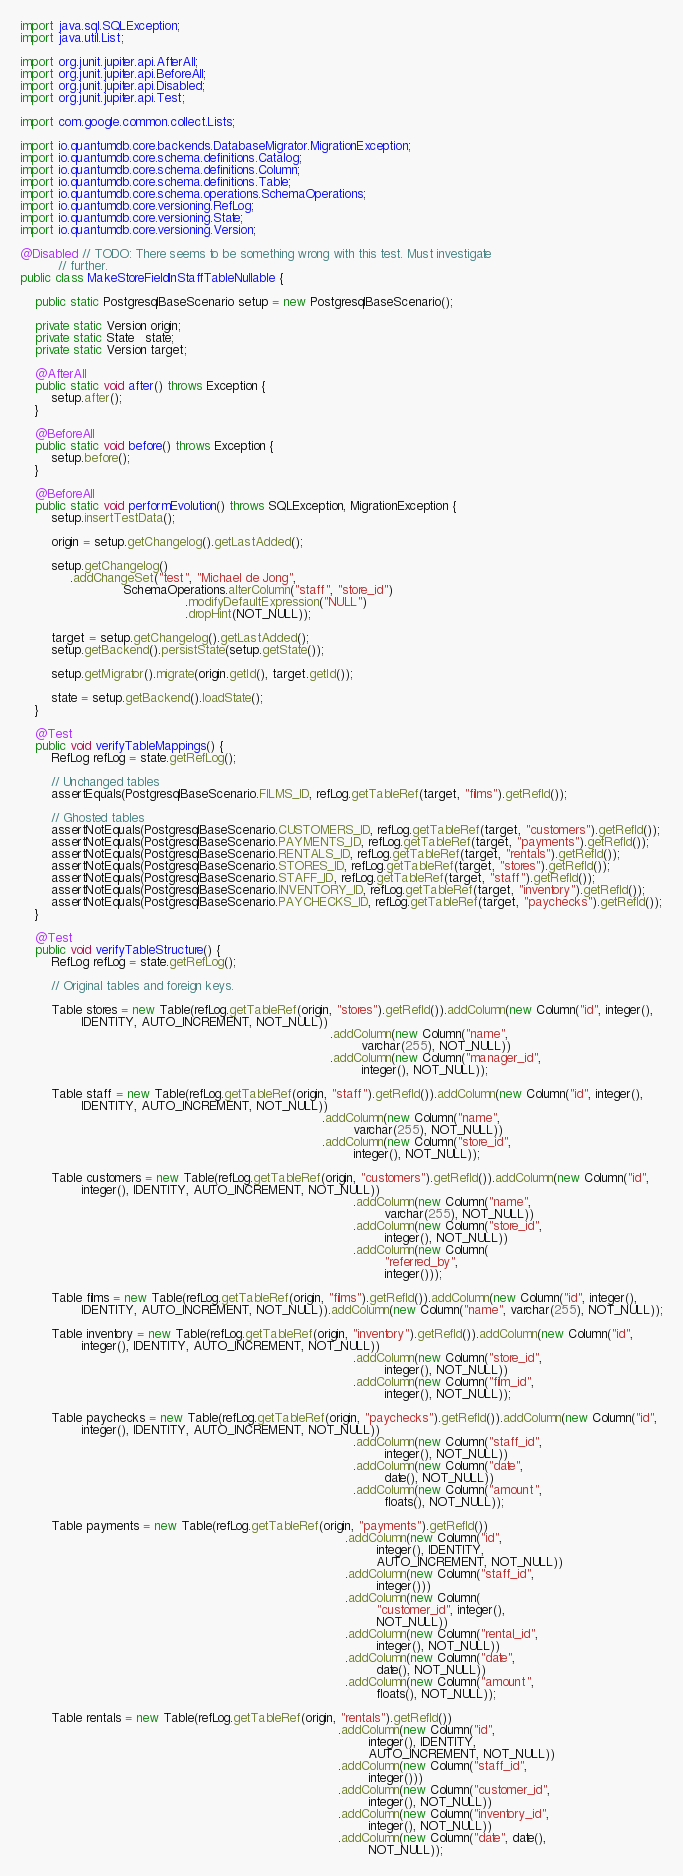<code> <loc_0><loc_0><loc_500><loc_500><_Java_>import java.sql.SQLException;
import java.util.List;

import org.junit.jupiter.api.AfterAll;
import org.junit.jupiter.api.BeforeAll;
import org.junit.jupiter.api.Disabled;
import org.junit.jupiter.api.Test;

import com.google.common.collect.Lists;

import io.quantumdb.core.backends.DatabaseMigrator.MigrationException;
import io.quantumdb.core.schema.definitions.Catalog;
import io.quantumdb.core.schema.definitions.Column;
import io.quantumdb.core.schema.definitions.Table;
import io.quantumdb.core.schema.operations.SchemaOperations;
import io.quantumdb.core.versioning.RefLog;
import io.quantumdb.core.versioning.State;
import io.quantumdb.core.versioning.Version;

@Disabled // TODO: There seems to be something wrong with this test. Must investigate
          // further.
public class MakeStoreFieldInStaffTableNullable {

    public static PostgresqlBaseScenario setup = new PostgresqlBaseScenario();

    private static Version origin;
    private static State   state;
    private static Version target;

    @AfterAll
    public static void after() throws Exception {
        setup.after();
    }

    @BeforeAll
    public static void before() throws Exception {
        setup.before();
    }

    @BeforeAll
    public static void performEvolution() throws SQLException, MigrationException {
        setup.insertTestData();

        origin = setup.getChangelog().getLastAdded();

        setup.getChangelog()
             .addChangeSet("test", "Michael de Jong",
                           SchemaOperations.alterColumn("staff", "store_id")
                                           .modifyDefaultExpression("NULL")
                                           .dropHint(NOT_NULL));

        target = setup.getChangelog().getLastAdded();
        setup.getBackend().persistState(setup.getState());

        setup.getMigrator().migrate(origin.getId(), target.getId());

        state = setup.getBackend().loadState();
    }

    @Test
    public void verifyTableMappings() {
        RefLog refLog = state.getRefLog();

        // Unchanged tables
        assertEquals(PostgresqlBaseScenario.FILMS_ID, refLog.getTableRef(target, "films").getRefId());

        // Ghosted tables
        assertNotEquals(PostgresqlBaseScenario.CUSTOMERS_ID, refLog.getTableRef(target, "customers").getRefId());
        assertNotEquals(PostgresqlBaseScenario.PAYMENTS_ID, refLog.getTableRef(target, "payments").getRefId());
        assertNotEquals(PostgresqlBaseScenario.RENTALS_ID, refLog.getTableRef(target, "rentals").getRefId());
        assertNotEquals(PostgresqlBaseScenario.STORES_ID, refLog.getTableRef(target, "stores").getRefId());
        assertNotEquals(PostgresqlBaseScenario.STAFF_ID, refLog.getTableRef(target, "staff").getRefId());
        assertNotEquals(PostgresqlBaseScenario.INVENTORY_ID, refLog.getTableRef(target, "inventory").getRefId());
        assertNotEquals(PostgresqlBaseScenario.PAYCHECKS_ID, refLog.getTableRef(target, "paychecks").getRefId());
    }

    @Test
    public void verifyTableStructure() {
        RefLog refLog = state.getRefLog();

        // Original tables and foreign keys.

        Table stores = new Table(refLog.getTableRef(origin, "stores").getRefId()).addColumn(new Column("id", integer(),
                IDENTITY, AUTO_INCREMENT, NOT_NULL))
                                                                                 .addColumn(new Column("name",
                                                                                         varchar(255), NOT_NULL))
                                                                                 .addColumn(new Column("manager_id",
                                                                                         integer(), NOT_NULL));

        Table staff = new Table(refLog.getTableRef(origin, "staff").getRefId()).addColumn(new Column("id", integer(),
                IDENTITY, AUTO_INCREMENT, NOT_NULL))
                                                                               .addColumn(new Column("name",
                                                                                       varchar(255), NOT_NULL))
                                                                               .addColumn(new Column("store_id",
                                                                                       integer(), NOT_NULL));

        Table customers = new Table(refLog.getTableRef(origin, "customers").getRefId()).addColumn(new Column("id",
                integer(), IDENTITY, AUTO_INCREMENT, NOT_NULL))
                                                                                       .addColumn(new Column("name",
                                                                                               varchar(255), NOT_NULL))
                                                                                       .addColumn(new Column("store_id",
                                                                                               integer(), NOT_NULL))
                                                                                       .addColumn(new Column(
                                                                                               "referred_by",
                                                                                               integer()));

        Table films = new Table(refLog.getTableRef(origin, "films").getRefId()).addColumn(new Column("id", integer(),
                IDENTITY, AUTO_INCREMENT, NOT_NULL)).addColumn(new Column("name", varchar(255), NOT_NULL));

        Table inventory = new Table(refLog.getTableRef(origin, "inventory").getRefId()).addColumn(new Column("id",
                integer(), IDENTITY, AUTO_INCREMENT, NOT_NULL))
                                                                                       .addColumn(new Column("store_id",
                                                                                               integer(), NOT_NULL))
                                                                                       .addColumn(new Column("film_id",
                                                                                               integer(), NOT_NULL));

        Table paychecks = new Table(refLog.getTableRef(origin, "paychecks").getRefId()).addColumn(new Column("id",
                integer(), IDENTITY, AUTO_INCREMENT, NOT_NULL))
                                                                                       .addColumn(new Column("staff_id",
                                                                                               integer(), NOT_NULL))
                                                                                       .addColumn(new Column("date",
                                                                                               date(), NOT_NULL))
                                                                                       .addColumn(new Column("amount",
                                                                                               floats(), NOT_NULL));

        Table payments = new Table(refLog.getTableRef(origin, "payments").getRefId())
                                                                                     .addColumn(new Column("id",
                                                                                             integer(), IDENTITY,
                                                                                             AUTO_INCREMENT, NOT_NULL))
                                                                                     .addColumn(new Column("staff_id",
                                                                                             integer()))
                                                                                     .addColumn(new Column(
                                                                                             "customer_id", integer(),
                                                                                             NOT_NULL))
                                                                                     .addColumn(new Column("rental_id",
                                                                                             integer(), NOT_NULL))
                                                                                     .addColumn(new Column("date",
                                                                                             date(), NOT_NULL))
                                                                                     .addColumn(new Column("amount",
                                                                                             floats(), NOT_NULL));

        Table rentals = new Table(refLog.getTableRef(origin, "rentals").getRefId())
                                                                                   .addColumn(new Column("id",
                                                                                           integer(), IDENTITY,
                                                                                           AUTO_INCREMENT, NOT_NULL))
                                                                                   .addColumn(new Column("staff_id",
                                                                                           integer()))
                                                                                   .addColumn(new Column("customer_id",
                                                                                           integer(), NOT_NULL))
                                                                                   .addColumn(new Column("inventory_id",
                                                                                           integer(), NOT_NULL))
                                                                                   .addColumn(new Column("date", date(),
                                                                                           NOT_NULL));
</code> 